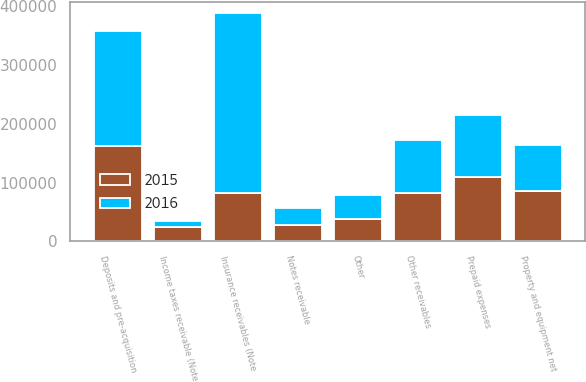<chart> <loc_0><loc_0><loc_500><loc_500><stacked_bar_chart><ecel><fcel>Insurance receivables (Note<fcel>Notes receivable<fcel>Other receivables<fcel>Prepaid expenses<fcel>Deposits and pre-acquisition<fcel>Property and equipment net<fcel>Income taxes receivable (Note<fcel>Other<nl><fcel>2016<fcel>307344<fcel>29111<fcel>90714<fcel>106748<fcel>195436<fcel>77444<fcel>9272<fcel>41357<nl><fcel>2015<fcel>81581<fcel>28288<fcel>81581<fcel>109113<fcel>162119<fcel>86312<fcel>25080<fcel>38172<nl></chart> 